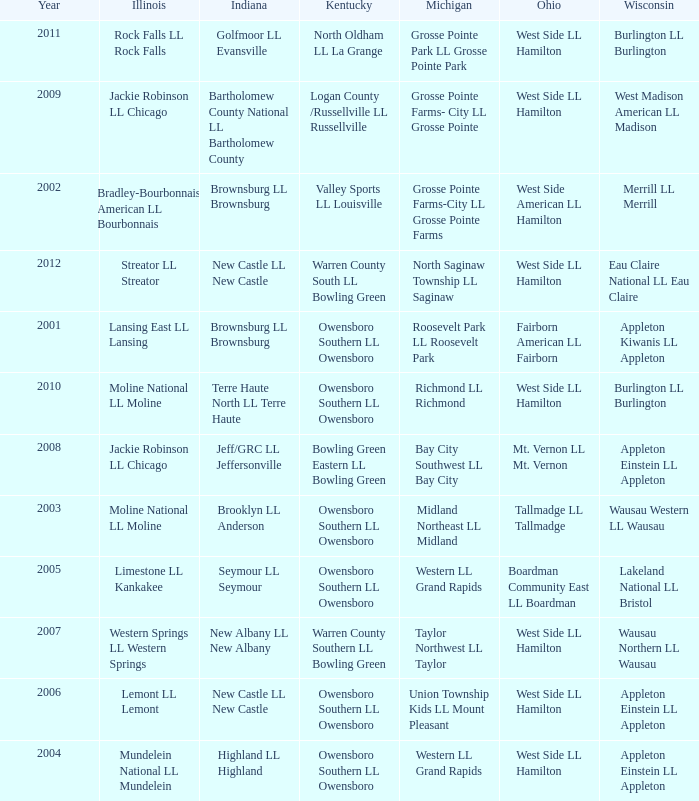Which little league team was from kentucky when the team from michigan was known as grosse pointe farms-city ll grosse pointe farms? Valley Sports LL Louisville. 